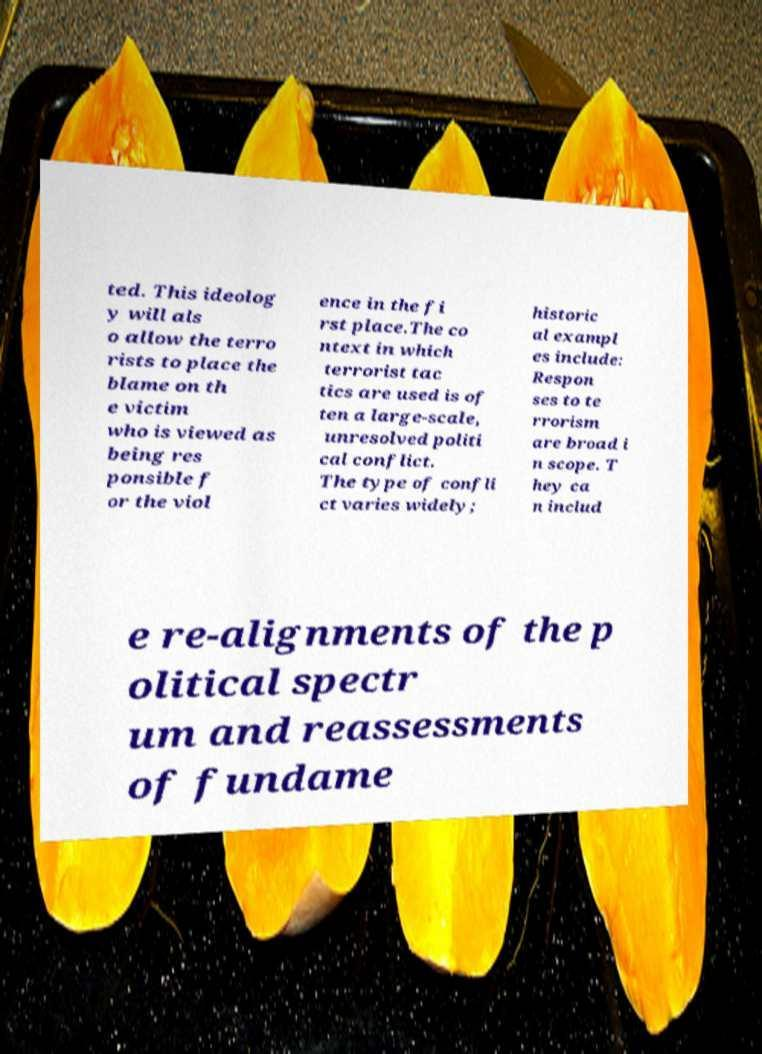Could you extract and type out the text from this image? ted. This ideolog y will als o allow the terro rists to place the blame on th e victim who is viewed as being res ponsible f or the viol ence in the fi rst place.The co ntext in which terrorist tac tics are used is of ten a large-scale, unresolved politi cal conflict. The type of confli ct varies widely; historic al exampl es include: Respon ses to te rrorism are broad i n scope. T hey ca n includ e re-alignments of the p olitical spectr um and reassessments of fundame 